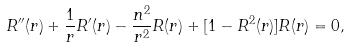Convert formula to latex. <formula><loc_0><loc_0><loc_500><loc_500>R ^ { \prime \prime } ( r ) + \frac { 1 } { r } R ^ { \prime } ( r ) - \frac { n ^ { 2 } } { r ^ { 2 } } R ( r ) + [ 1 - R ^ { 2 } ( r ) ] R ( r ) = 0 ,</formula> 